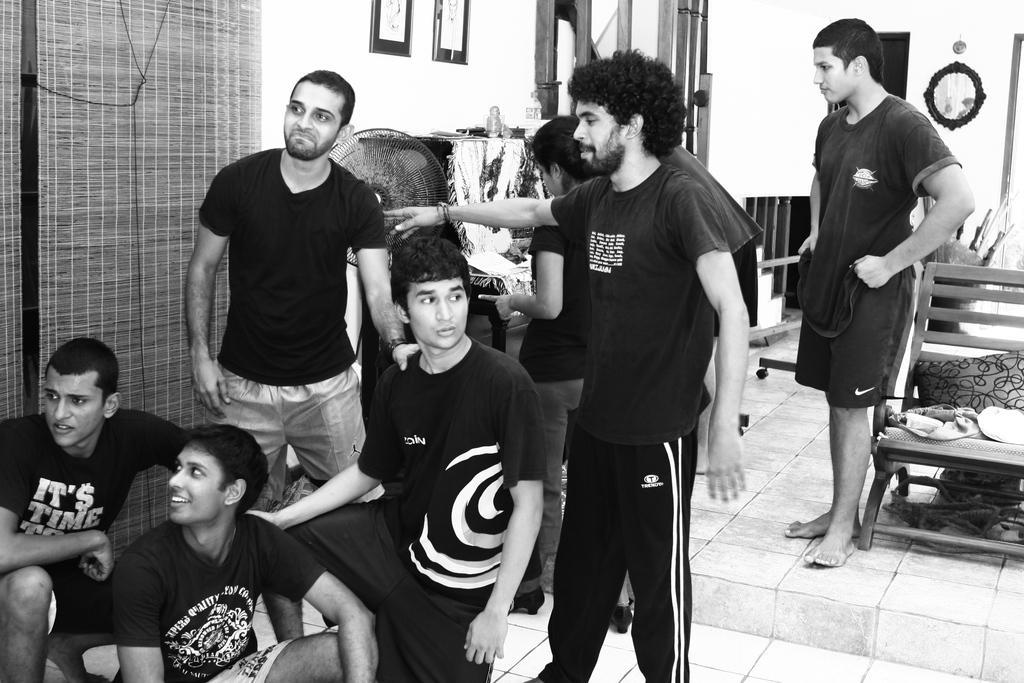Can you describe this image briefly? This is a black and white image. In this picture we can see some persons, chairs, table, some objects, curtain, wall, photo frame, mirror, cupboards. At the bottom of the image there is a floor. 